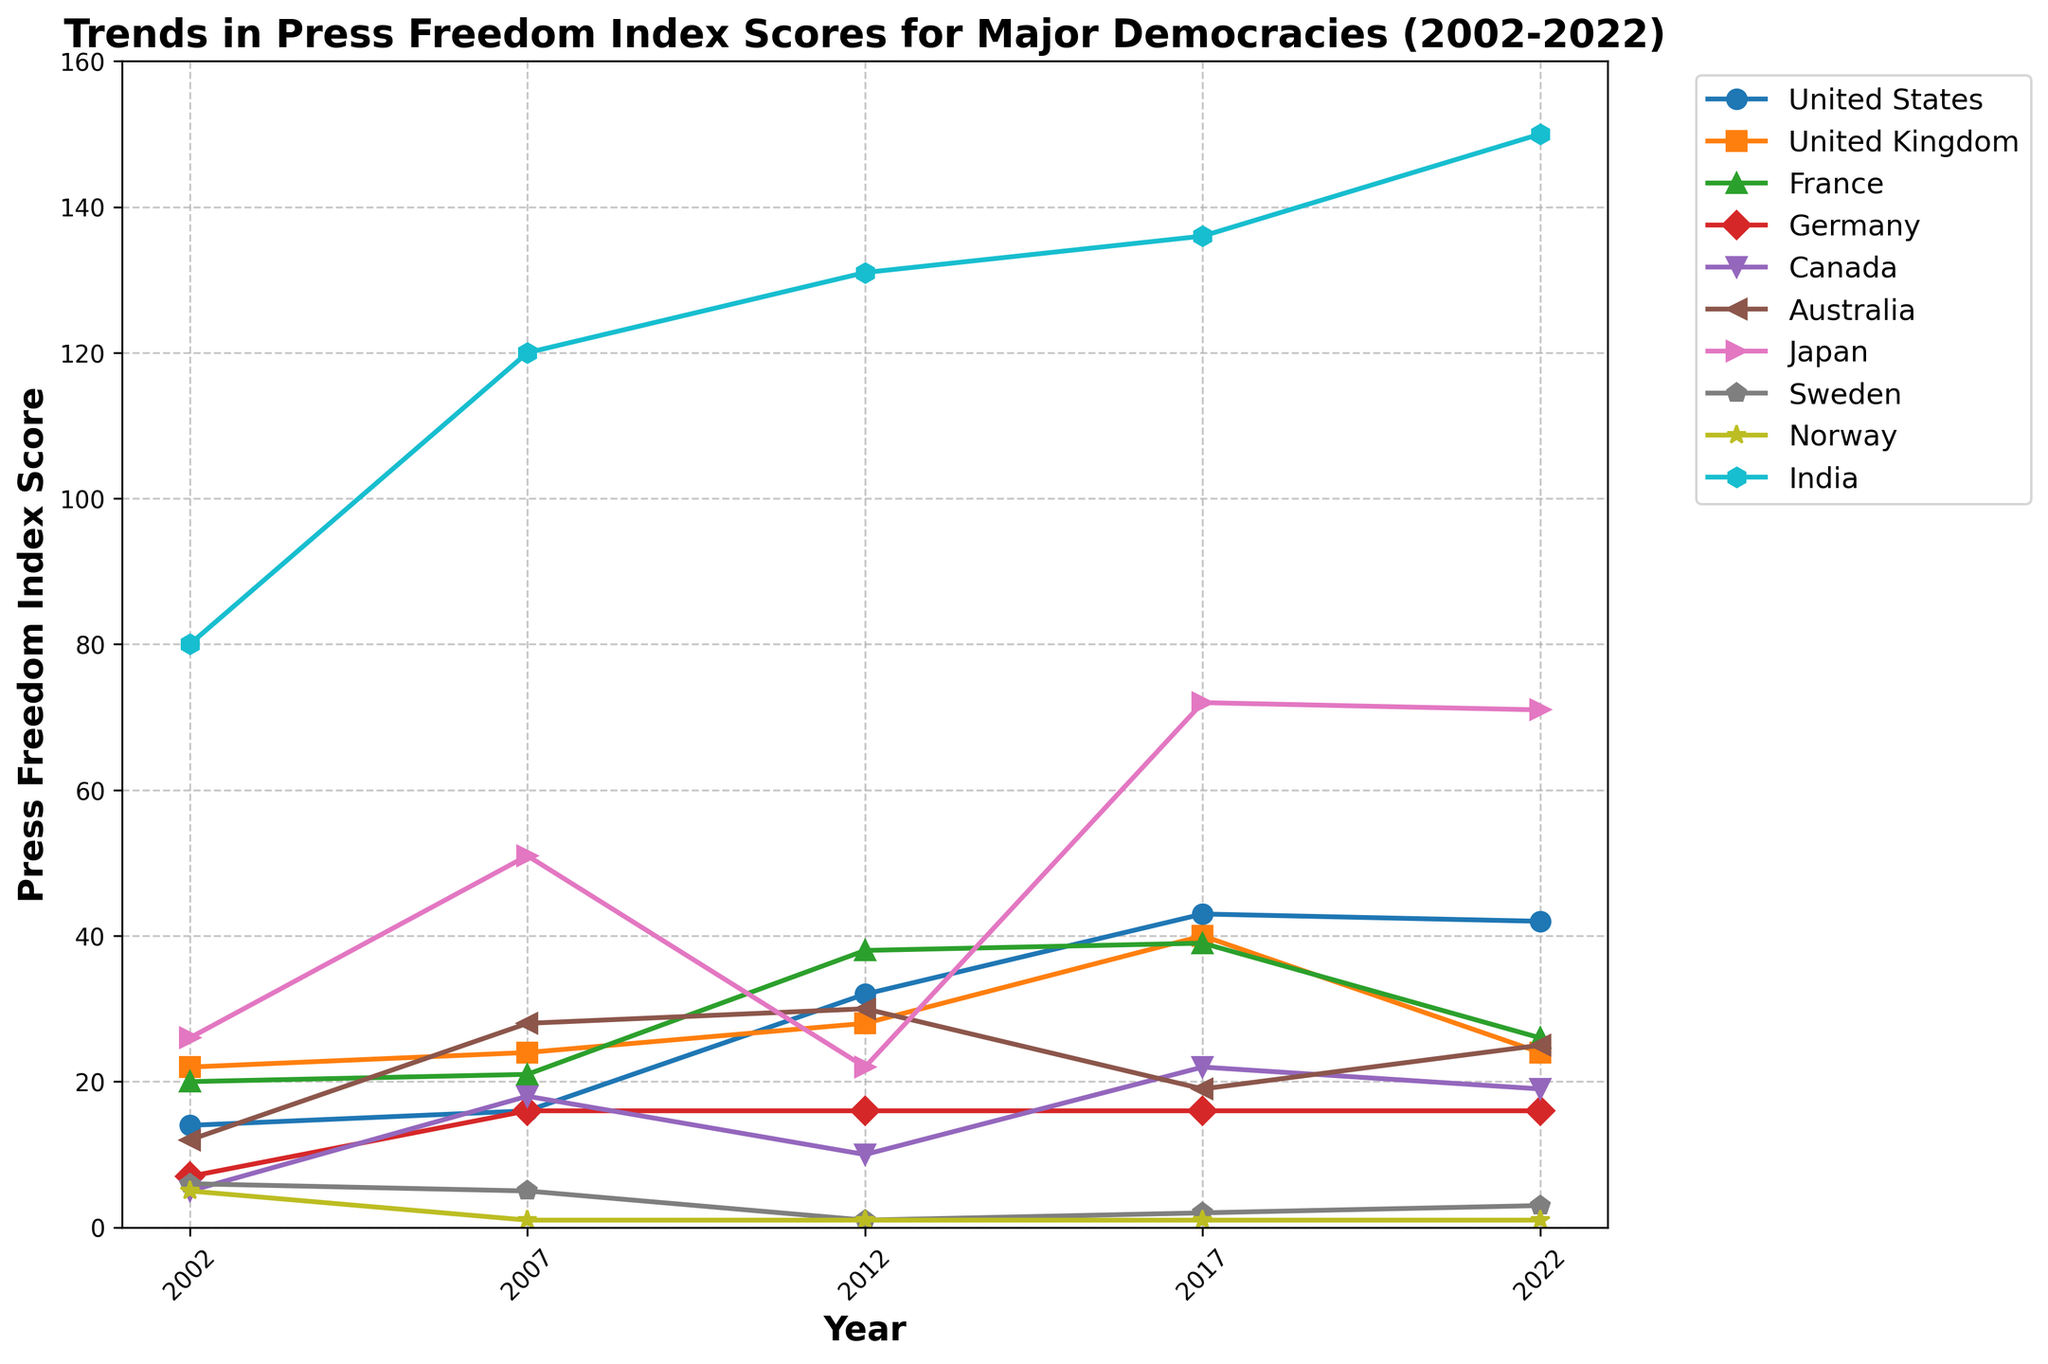What’s the average Press Freedom Index score for Germany over the displayed years? To find the average, add Germany's scores (7, 16, 16, 16, 16) and divide by the number of scores: (7 + 16 + 16 + 16 + 16) / 5 = 71 / 5 = 14.2.
Answer: 14.2 Which country had a higher Press Freedom Index score in 2022, Australia or France? Compare the Press Freedom Index scores in 2022 for both countries: Australia (25) and France (26). France had a higher score.
Answer: France In which year did Japan experience its highest Press Freedom Index score? By looking at Japan’s scores over the years, the highest score is 72, which occurred in 2017.
Answer: 2017 How did the Press Freedom Index scores for the United States change from 2002 to 2022? To see the change, subtract the 2002 score from the 2022 score for the United States: 42 - 14 = 28. The score increased by 28 points.
Answer: increased by 28 points Which country consistently held the position with the lowest Press Freedom Index score across all years? Check the scores for each year and see which country consistently had the lowest scores. Norway had the lowest score across all years with scores of (5, 1, 1, 1, 1).
Answer: Norway How does the average Press Freedom Index score for Canada compare to the average score for Australia from 2002 to 2022? Calculate the averages: Canada (5, 18, 10, 22, 19) = (5 + 18 + 10 + 22 + 19) / 5 = 14.8, and Australia (12, 28, 30, 19, 25) = (12 + 28 + 30 + 19 + 25) / 5 = 22.8. Compare: Canada 14.8 and Australia 22.8; Canada has a lower average score.
Answer: Canada has a lower average score Did India’s Press Freedom Index score improve or worsen over the years? Look at India's scores, which increased from 80 in 2002 to 150 in 2022, indicating a worsening score.
Answer: worsened Among the shown years, in which year did the United Kingdom see the biggest increase in its Press Freedom Index score compared to the previous year? Calculate year-over-year differences: (2022-2017: 24 - 40 = -16), (2017-2012: 40 - 28 = 12), (2012-2007: 28 - 24 = 4), (2007-2002: 24 - 22 = 2). The biggest increase occurred between 2012 and 2017 (12 points).
Answer: 2012-2017 